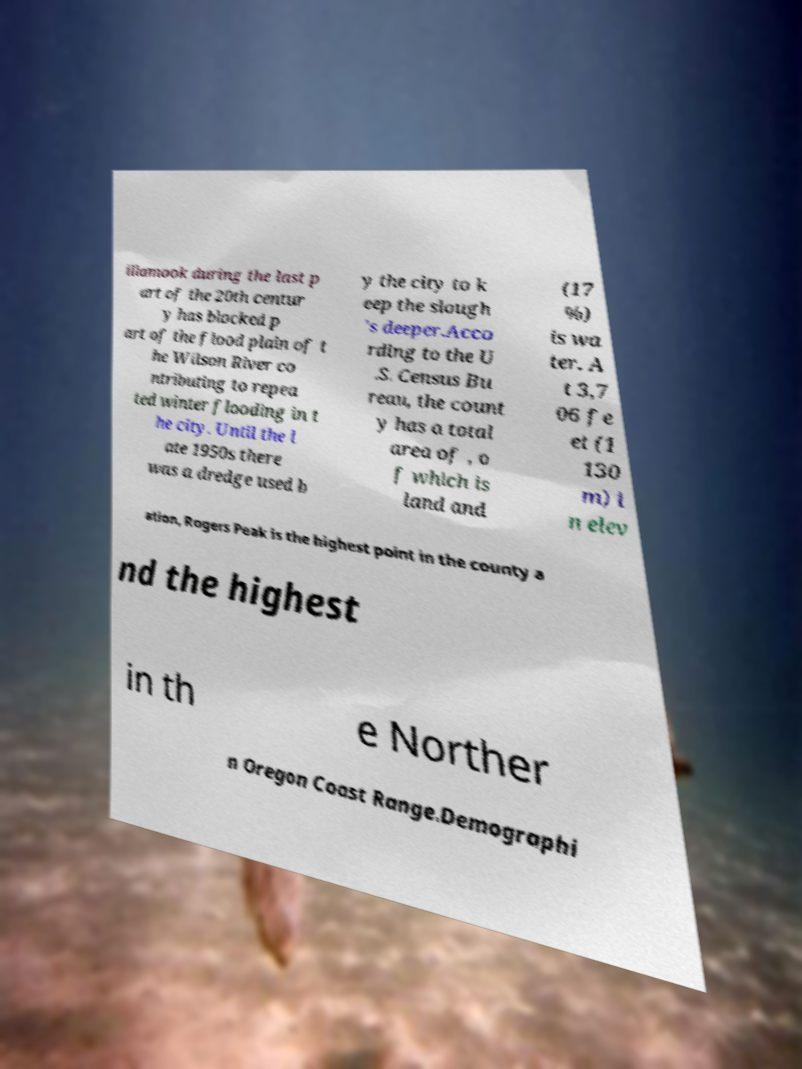Please identify and transcribe the text found in this image. illamook during the last p art of the 20th centur y has blocked p art of the flood plain of t he Wilson River co ntributing to repea ted winter flooding in t he city. Until the l ate 1950s there was a dredge used b y the city to k eep the slough 's deeper.Acco rding to the U .S. Census Bu reau, the count y has a total area of , o f which is land and (17 %) is wa ter. A t 3,7 06 fe et (1 130 m) i n elev ation, Rogers Peak is the highest point in the county a nd the highest in th e Norther n Oregon Coast Range.Demographi 